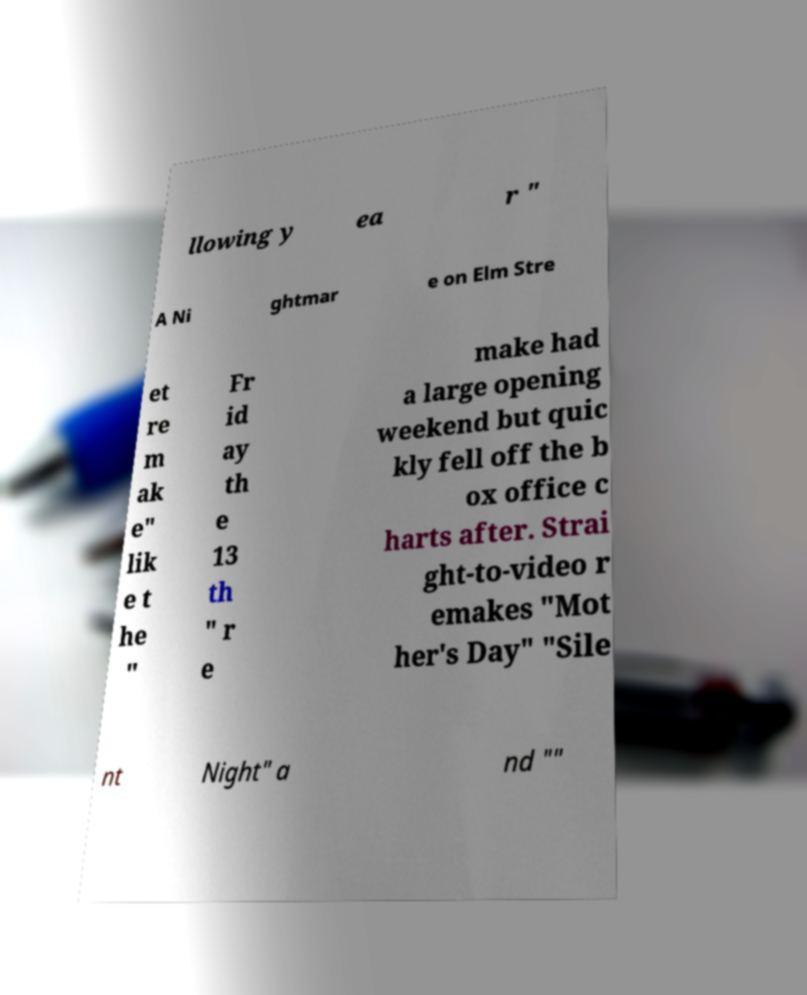There's text embedded in this image that I need extracted. Can you transcribe it verbatim? llowing y ea r " A Ni ghtmar e on Elm Stre et re m ak e" lik e t he " Fr id ay th e 13 th " r e make had a large opening weekend but quic kly fell off the b ox office c harts after. Strai ght-to-video r emakes "Mot her's Day" "Sile nt Night" a nd "" 